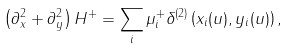Convert formula to latex. <formula><loc_0><loc_0><loc_500><loc_500>\left ( \partial _ { x } ^ { 2 } + \partial _ { y } ^ { 2 } \right ) H ^ { + } = \sum _ { i } \mu _ { i } ^ { + } \delta ^ { ( 2 ) } \left ( x _ { i } ( u ) , y _ { i } ( u ) \right ) ,</formula> 